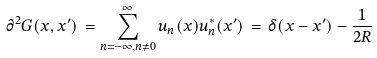Convert formula to latex. <formula><loc_0><loc_0><loc_500><loc_500>{ \partial } ^ { 2 } G ( x , x ^ { \prime } ) \, = \sum _ { n = - \infty , n \neq 0 } ^ { \infty } u _ { n } ( x ) u ^ { * } _ { n } ( x ^ { \prime } ) \, = \, \delta ( x - x ^ { \prime } ) - \frac { 1 } { 2 R }</formula> 